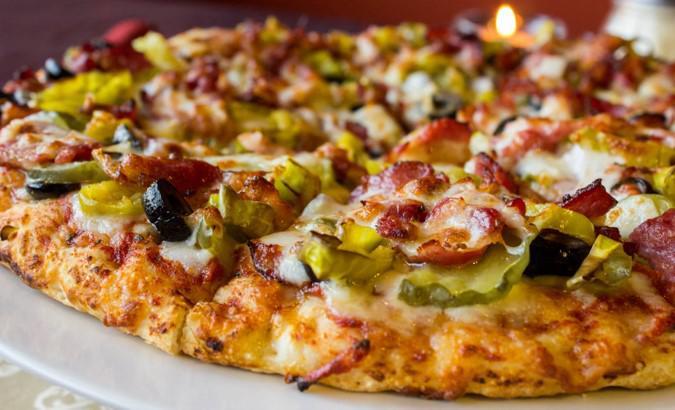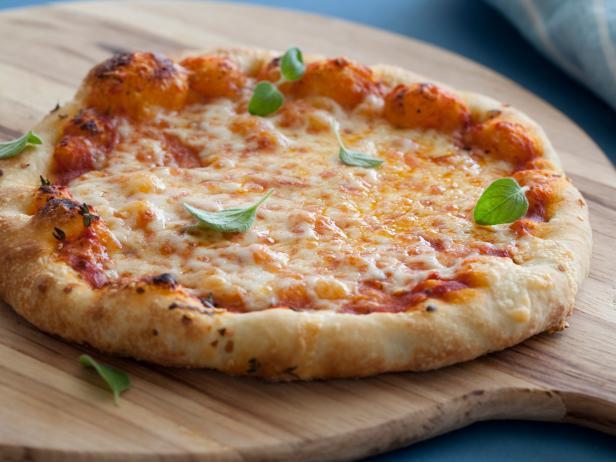The first image is the image on the left, the second image is the image on the right. Analyze the images presented: Is the assertion "A whole cooked pizza is on a white plate." valid? Answer yes or no. Yes. 